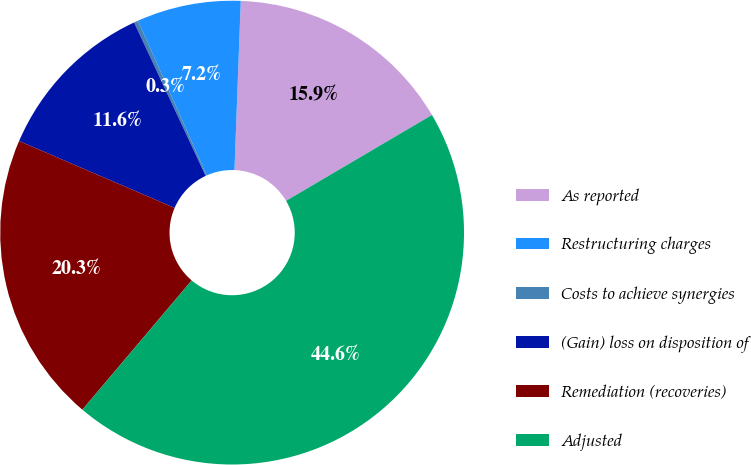<chart> <loc_0><loc_0><loc_500><loc_500><pie_chart><fcel>As reported<fcel>Restructuring charges<fcel>Costs to achieve synergies<fcel>(Gain) loss on disposition of<fcel>Remediation (recoveries)<fcel>Adjusted<nl><fcel>15.94%<fcel>7.25%<fcel>0.29%<fcel>11.59%<fcel>20.29%<fcel>44.64%<nl></chart> 